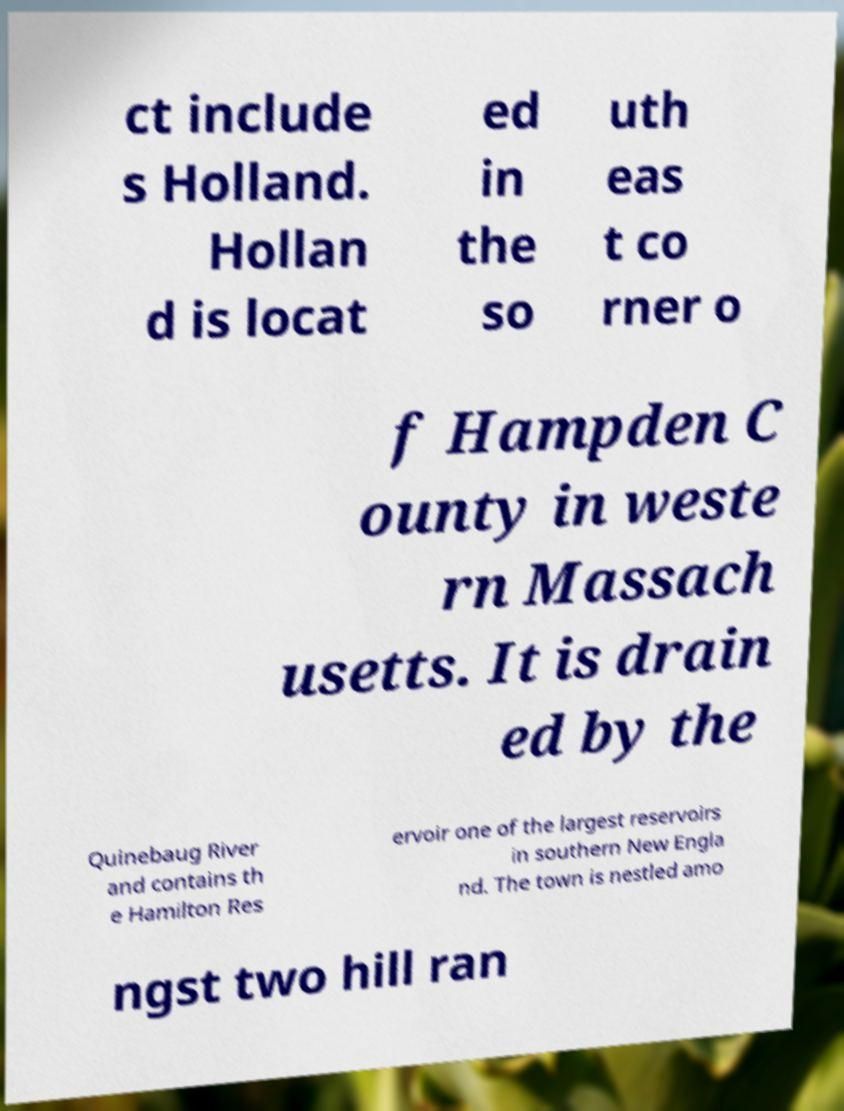Can you read and provide the text displayed in the image?This photo seems to have some interesting text. Can you extract and type it out for me? ct include s Holland. Hollan d is locat ed in the so uth eas t co rner o f Hampden C ounty in weste rn Massach usetts. It is drain ed by the Quinebaug River and contains th e Hamilton Res ervoir one of the largest reservoirs in southern New Engla nd. The town is nestled amo ngst two hill ran 